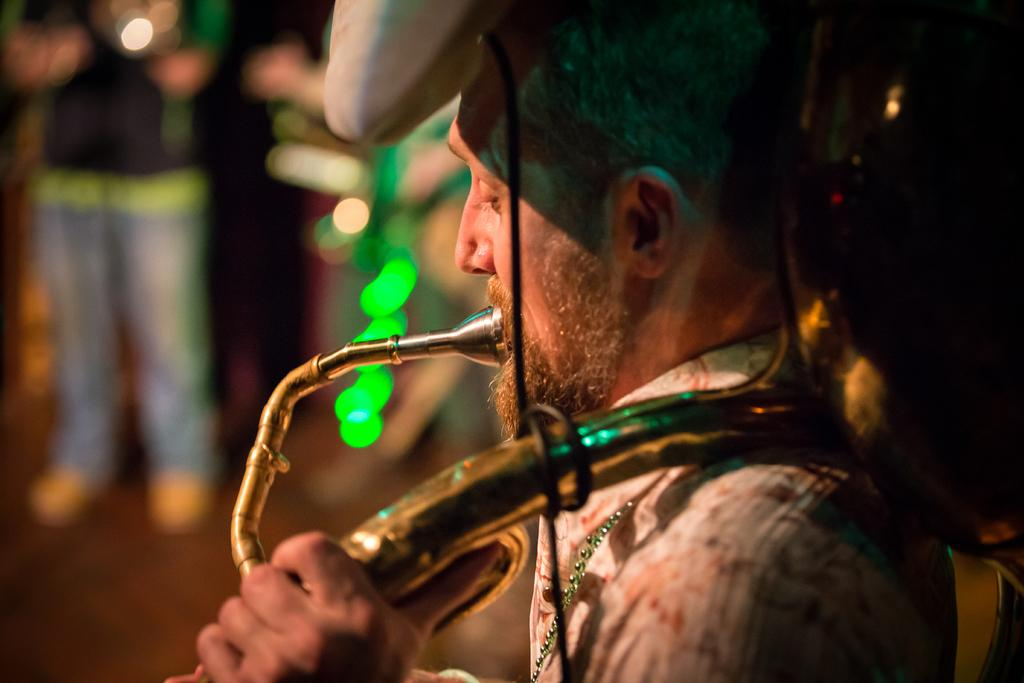What is the man in the image doing? The man is playing a musical instrument in the image. Where is the man located in the image? The man is in the front of the image. What can be seen in the background of the image? There are people in the background of the image. How is the background of the image depicted? The background is blurred. What type of meal is the man eating in the image? There is no meal present in the image; the man is playing a musical instrument. Where is the doll located in the image? There is no doll present in the image. 